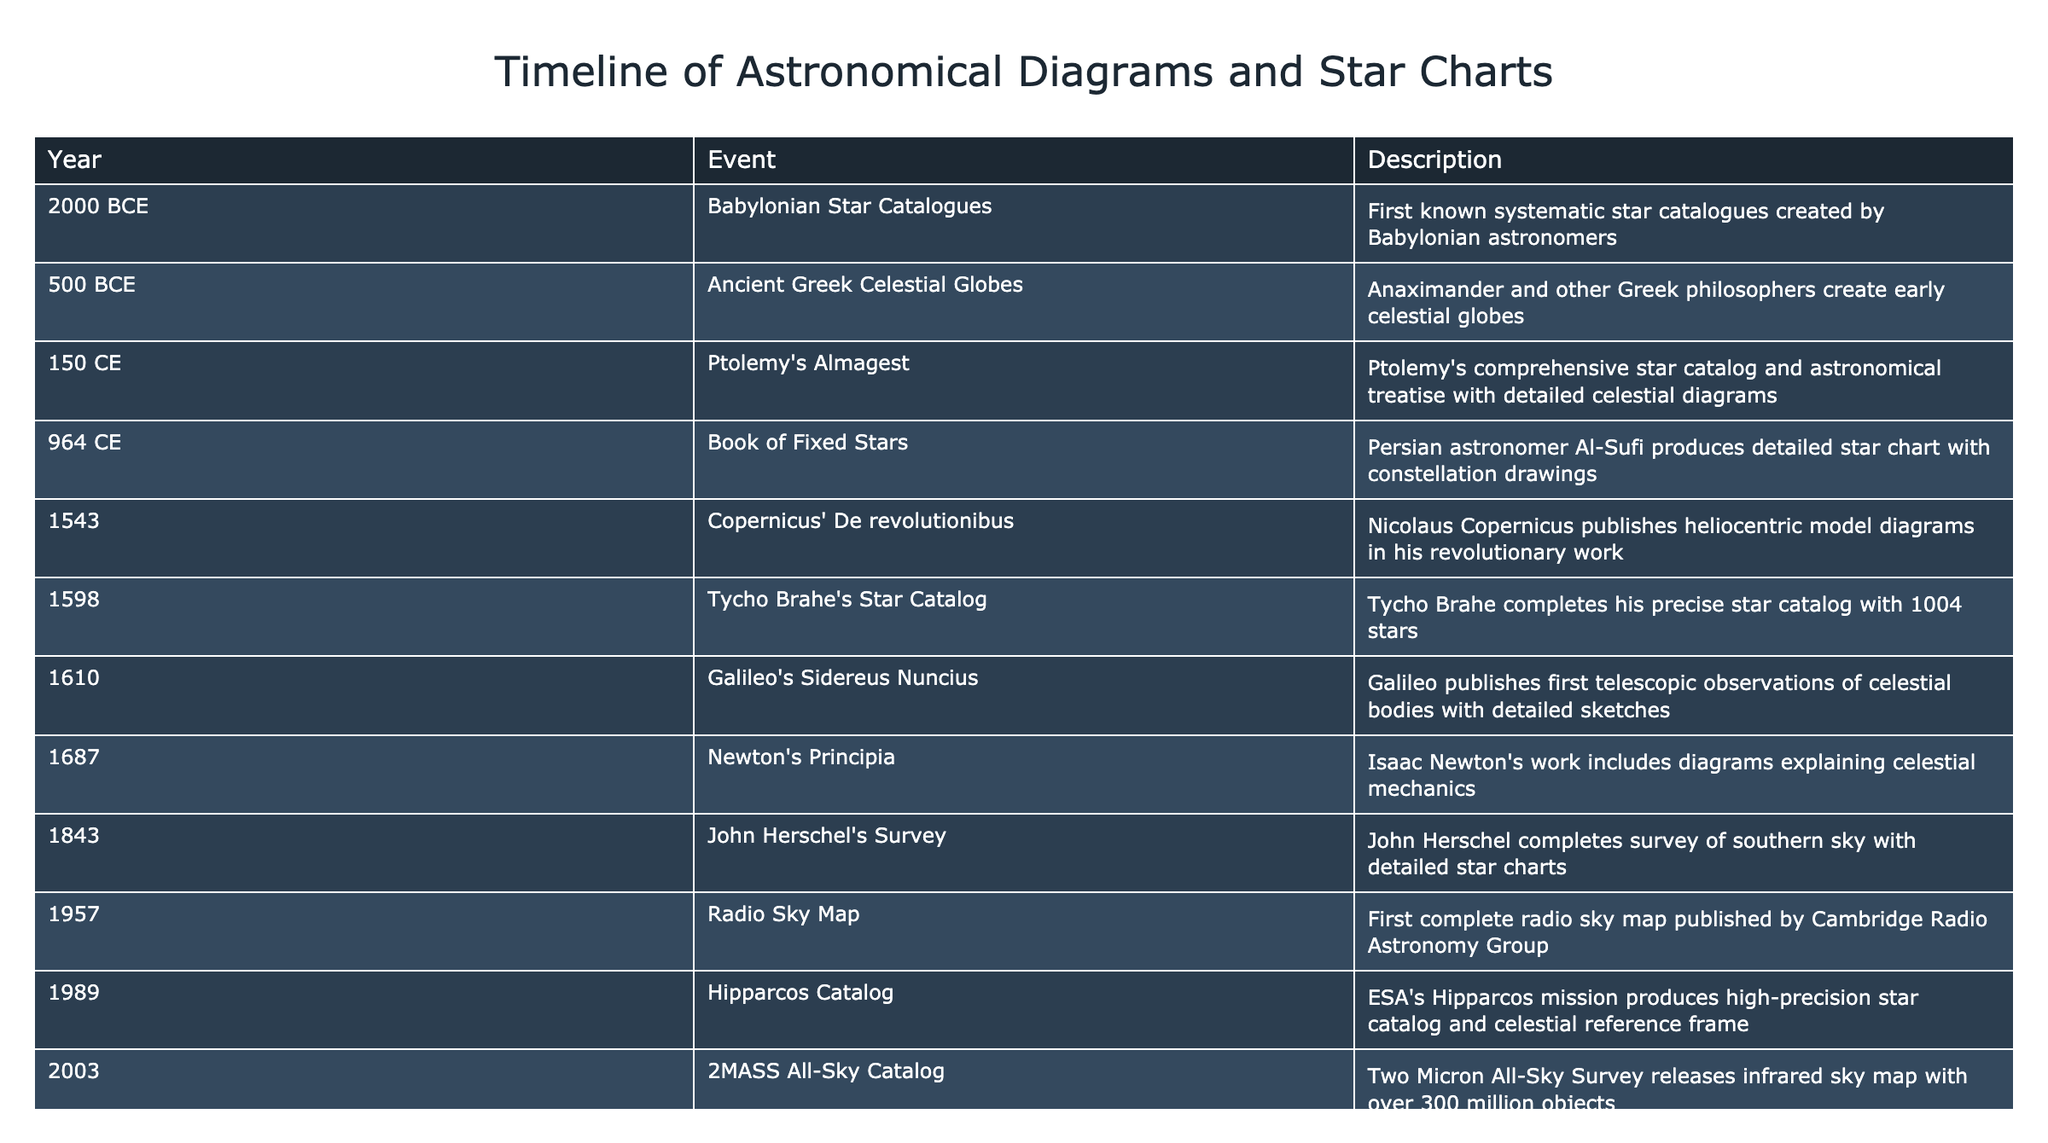What is the earliest notable event related to astronomical diagrams? The earliest notable event is recorded in 2000 BCE when the Babylonians created the first systematic star catalogues. This event is listed at the top of the timeline, indicating its significance in the history of astronomical illustrations.
Answer: Babylonian Star Catalogues Which astronomer is associated with the creation of celestial globes around 500 BCE? The table indicates that Greek philosopher Anaximander and others are associated with the creation of early celestial globes in 500 BCE. This information can be found in the row corresponding to that year.
Answer: Anaximander How many stars were included in Tycho Brahe's star catalog completed in 1598? According to the table, Tycho Brahe's star catalog includes 1004 stars. This information can be directly retrieved from the entry for that year.
Answer: 1004 stars Was the first telescopic observation of celestial bodies published by Galileo? Yes, the table confirms this fact in the 1610 entry where it mentions Galileo's publication of detailed sketches of celestial bodies based on his observations.
Answer: Yes How many events listed occurred before the year 1000 CE? The table shows a total of four events (Babylonian Star Catalogues, Ancient Greek Celestial Globes, Ptolemy's Almagest, and Book of Fixed Stars) occurred before 1000 CE. This count can be obtained by simply filtering for years less than 1000 CE in the timeline.
Answer: 4 events What was the trend in published astronomical diagrams from the 150 CE event until the 1500s? To observe the trend, start from Ptolemy's comprehensive star catalog in 150 CE through to Copernicus' work in 1543, noticing that publications are gradually becoming more detailed and geometrically complex, reflecting the evolution in understanding of celestial mechanics during that period. This involves analyzing the descriptions of each event listed.
Answer: Increasing complexity and detail Which event revealed high-precision star catalog data after 1980? The Hipparcos Catalog was published in 1989, and it is noted in the table as the first project that provided high-precision star catalog data after 1980. This is identifiable in the row for that particular year.
Answer: Hipparcos Catalog What was the most recent event listed related to astronomical diagrams, and what did it release? The most recent event in the table is the Gaia DR2 in 2018, which released precise positions of 1.7 billion stars. This is indicated at the bottom of the timeline, showcasing the most modern advancement in the field.
Answer: Gaia DR2 released positions of 1.7 billion stars 